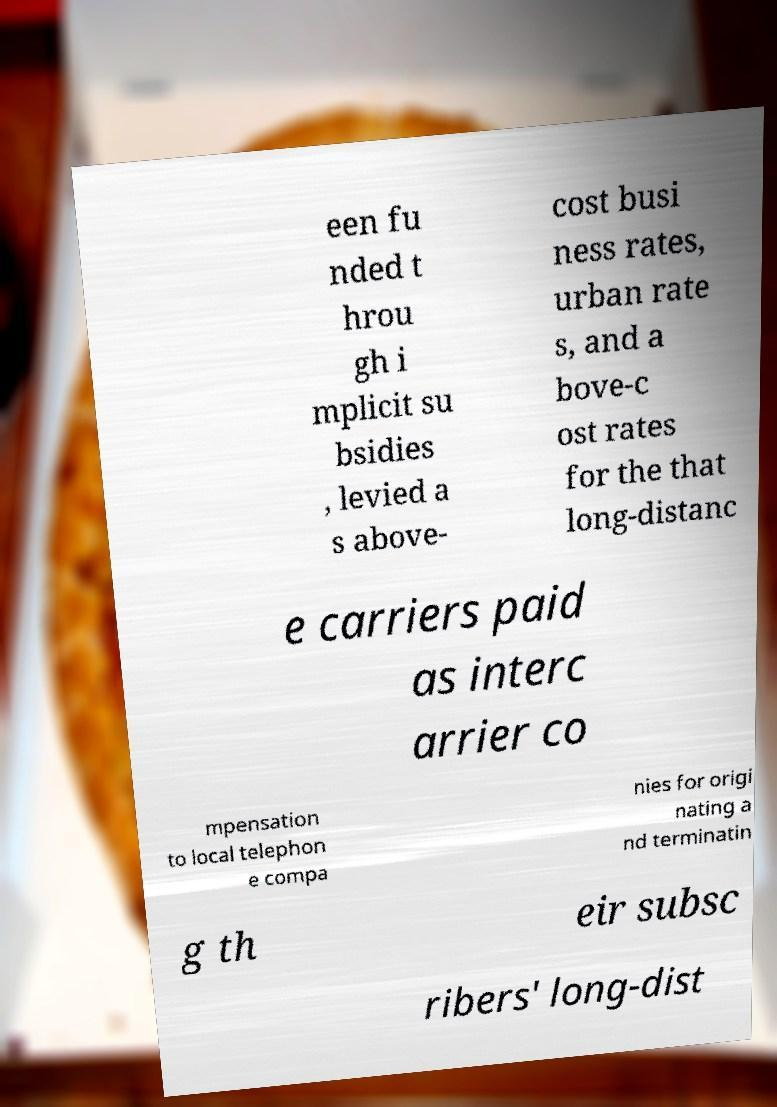Please identify and transcribe the text found in this image. een fu nded t hrou gh i mplicit su bsidies , levied a s above- cost busi ness rates, urban rate s, and a bove-c ost rates for the that long-distanc e carriers paid as interc arrier co mpensation to local telephon e compa nies for origi nating a nd terminatin g th eir subsc ribers' long-dist 